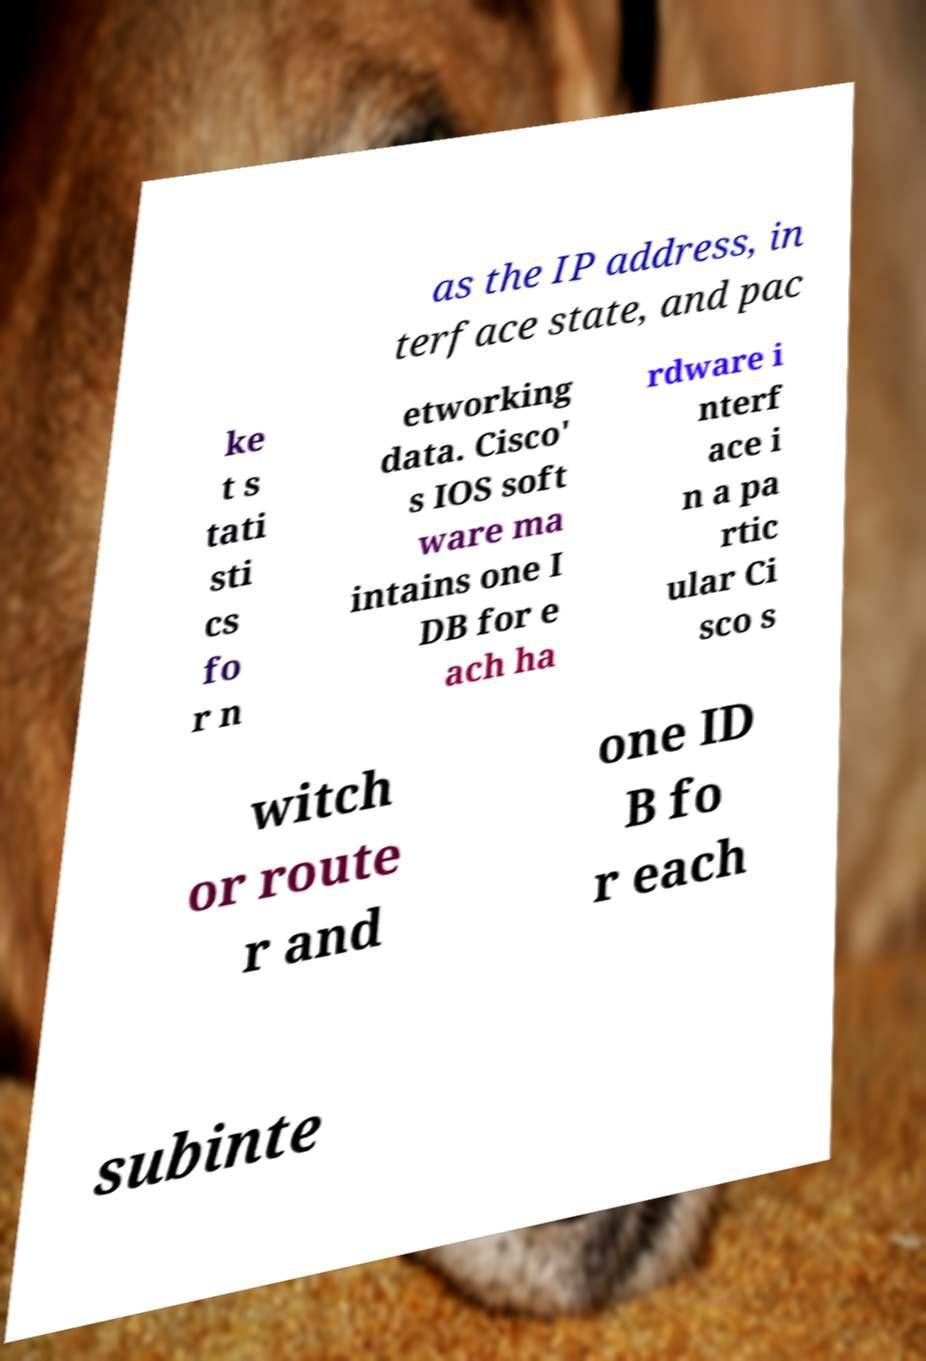Could you extract and type out the text from this image? as the IP address, in terface state, and pac ke t s tati sti cs fo r n etworking data. Cisco' s IOS soft ware ma intains one I DB for e ach ha rdware i nterf ace i n a pa rtic ular Ci sco s witch or route r and one ID B fo r each subinte 